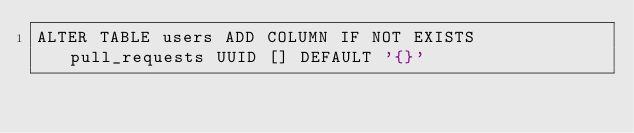Convert code to text. <code><loc_0><loc_0><loc_500><loc_500><_SQL_>ALTER TABLE users ADD COLUMN IF NOT EXISTS pull_requests UUID [] DEFAULT '{}'
</code> 